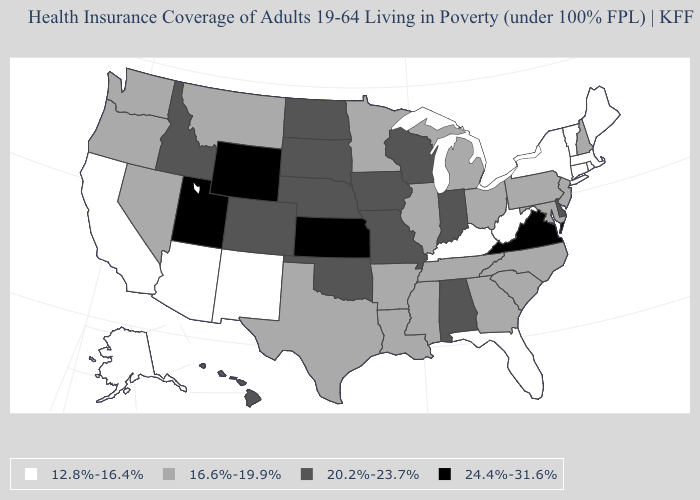Name the states that have a value in the range 16.6%-19.9%?
Give a very brief answer. Arkansas, Georgia, Illinois, Louisiana, Maryland, Michigan, Minnesota, Mississippi, Montana, Nevada, New Hampshire, New Jersey, North Carolina, Ohio, Oregon, Pennsylvania, South Carolina, Tennessee, Texas, Washington. Name the states that have a value in the range 20.2%-23.7%?
Give a very brief answer. Alabama, Colorado, Delaware, Hawaii, Idaho, Indiana, Iowa, Missouri, Nebraska, North Dakota, Oklahoma, South Dakota, Wisconsin. What is the value of West Virginia?
Write a very short answer. 12.8%-16.4%. Is the legend a continuous bar?
Quick response, please. No. Among the states that border Michigan , does Indiana have the lowest value?
Be succinct. No. What is the value of Washington?
Write a very short answer. 16.6%-19.9%. Name the states that have a value in the range 24.4%-31.6%?
Write a very short answer. Kansas, Utah, Virginia, Wyoming. Name the states that have a value in the range 24.4%-31.6%?
Keep it brief. Kansas, Utah, Virginia, Wyoming. Does Arkansas have the lowest value in the South?
Concise answer only. No. What is the lowest value in the MidWest?
Write a very short answer. 16.6%-19.9%. What is the value of Louisiana?
Give a very brief answer. 16.6%-19.9%. What is the highest value in the USA?
Give a very brief answer. 24.4%-31.6%. Name the states that have a value in the range 16.6%-19.9%?
Give a very brief answer. Arkansas, Georgia, Illinois, Louisiana, Maryland, Michigan, Minnesota, Mississippi, Montana, Nevada, New Hampshire, New Jersey, North Carolina, Ohio, Oregon, Pennsylvania, South Carolina, Tennessee, Texas, Washington. Does Delaware have a lower value than Utah?
Write a very short answer. Yes. Name the states that have a value in the range 20.2%-23.7%?
Write a very short answer. Alabama, Colorado, Delaware, Hawaii, Idaho, Indiana, Iowa, Missouri, Nebraska, North Dakota, Oklahoma, South Dakota, Wisconsin. 